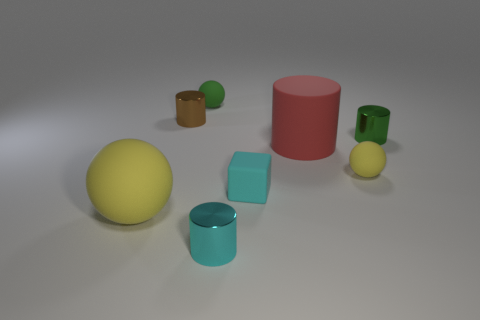Subtract all purple cylinders. Subtract all purple blocks. How many cylinders are left? 4 Add 1 tiny purple rubber spheres. How many objects exist? 9 Subtract all spheres. How many objects are left? 5 Add 3 small yellow rubber spheres. How many small yellow rubber spheres are left? 4 Add 4 small rubber things. How many small rubber things exist? 7 Subtract 0 yellow cubes. How many objects are left? 8 Subtract all brown things. Subtract all cyan shiny spheres. How many objects are left? 7 